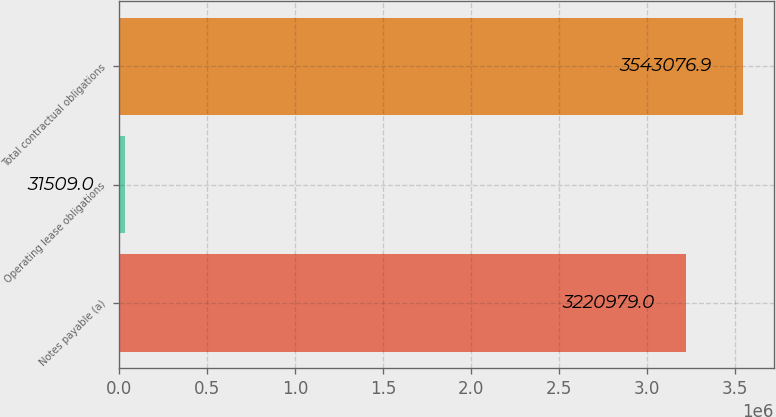Convert chart to OTSL. <chart><loc_0><loc_0><loc_500><loc_500><bar_chart><fcel>Notes payable (a)<fcel>Operating lease obligations<fcel>Total contractual obligations<nl><fcel>3.22098e+06<fcel>31509<fcel>3.54308e+06<nl></chart> 